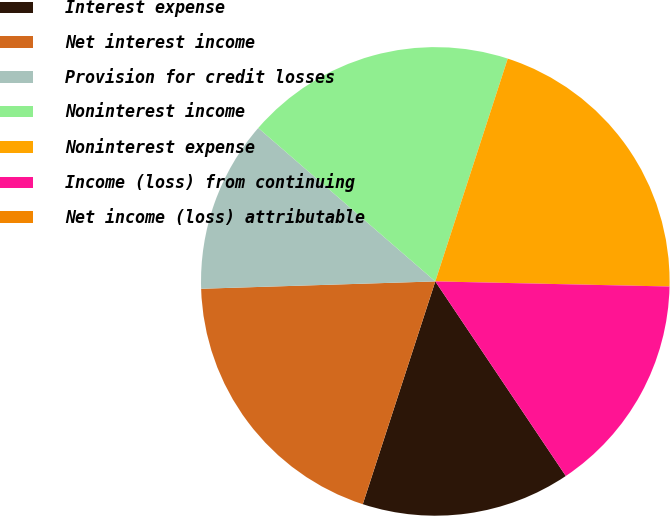<chart> <loc_0><loc_0><loc_500><loc_500><pie_chart><fcel>Interest expense<fcel>Net interest income<fcel>Provision for credit losses<fcel>Noninterest income<fcel>Noninterest expense<fcel>Income (loss) from continuing<fcel>Net income (loss) attributable<nl><fcel>14.41%<fcel>19.49%<fcel>11.86%<fcel>18.64%<fcel>20.34%<fcel>15.25%<fcel>0.0%<nl></chart> 